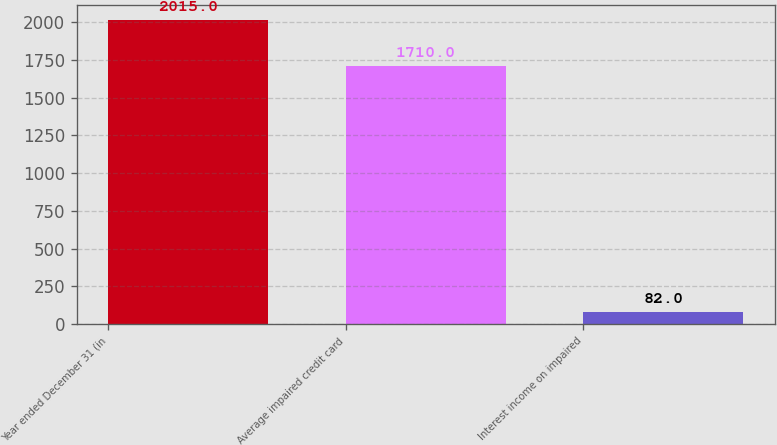<chart> <loc_0><loc_0><loc_500><loc_500><bar_chart><fcel>Year ended December 31 (in<fcel>Average impaired credit card<fcel>Interest income on impaired<nl><fcel>2015<fcel>1710<fcel>82<nl></chart> 